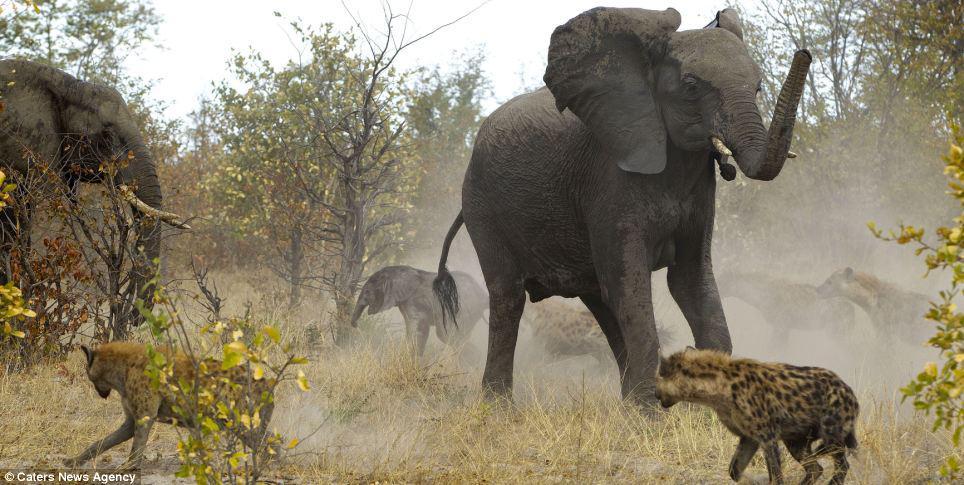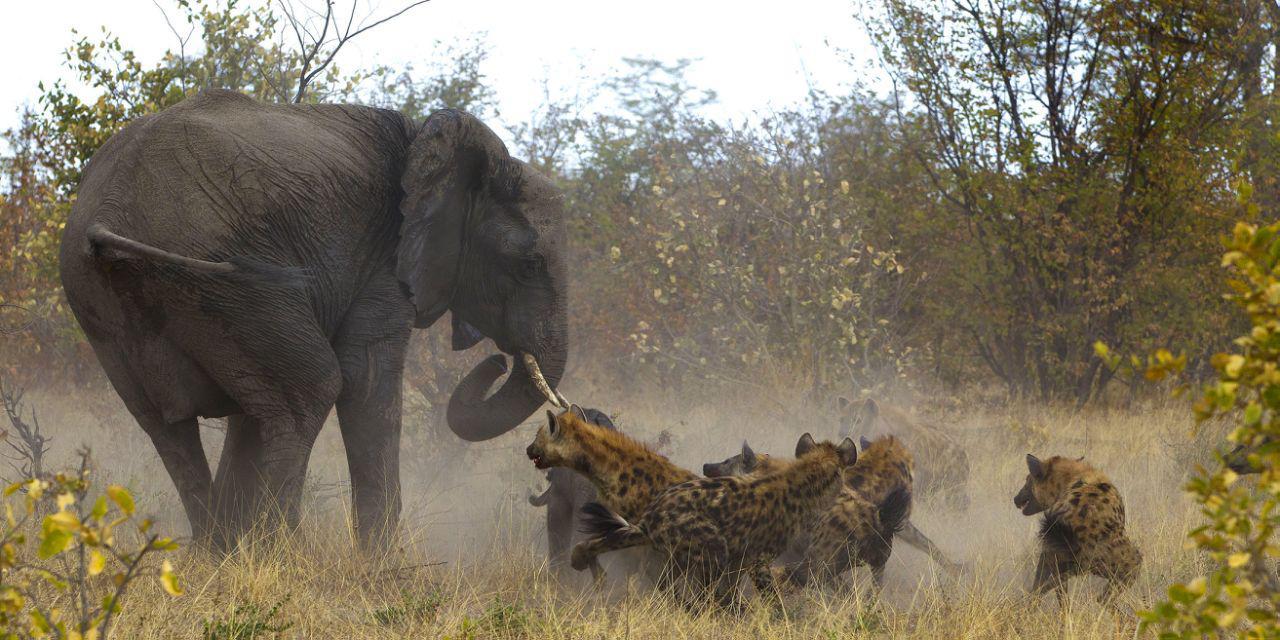The first image is the image on the left, the second image is the image on the right. Considering the images on both sides, is "The left image shows a hyena in front of an elephant which has its head angled toward the camera and its ears fanning out." valid? Answer yes or no. Yes. The first image is the image on the left, the second image is the image on the right. Considering the images on both sides, is "Each image shows an elephant in a similar forward charging pose near hyenas." valid? Answer yes or no. No. The first image is the image on the left, the second image is the image on the right. Examine the images to the left and right. Is the description "In one of the images, there are more than two hyenas crowding the baby elephant." accurate? Answer yes or no. Yes. 